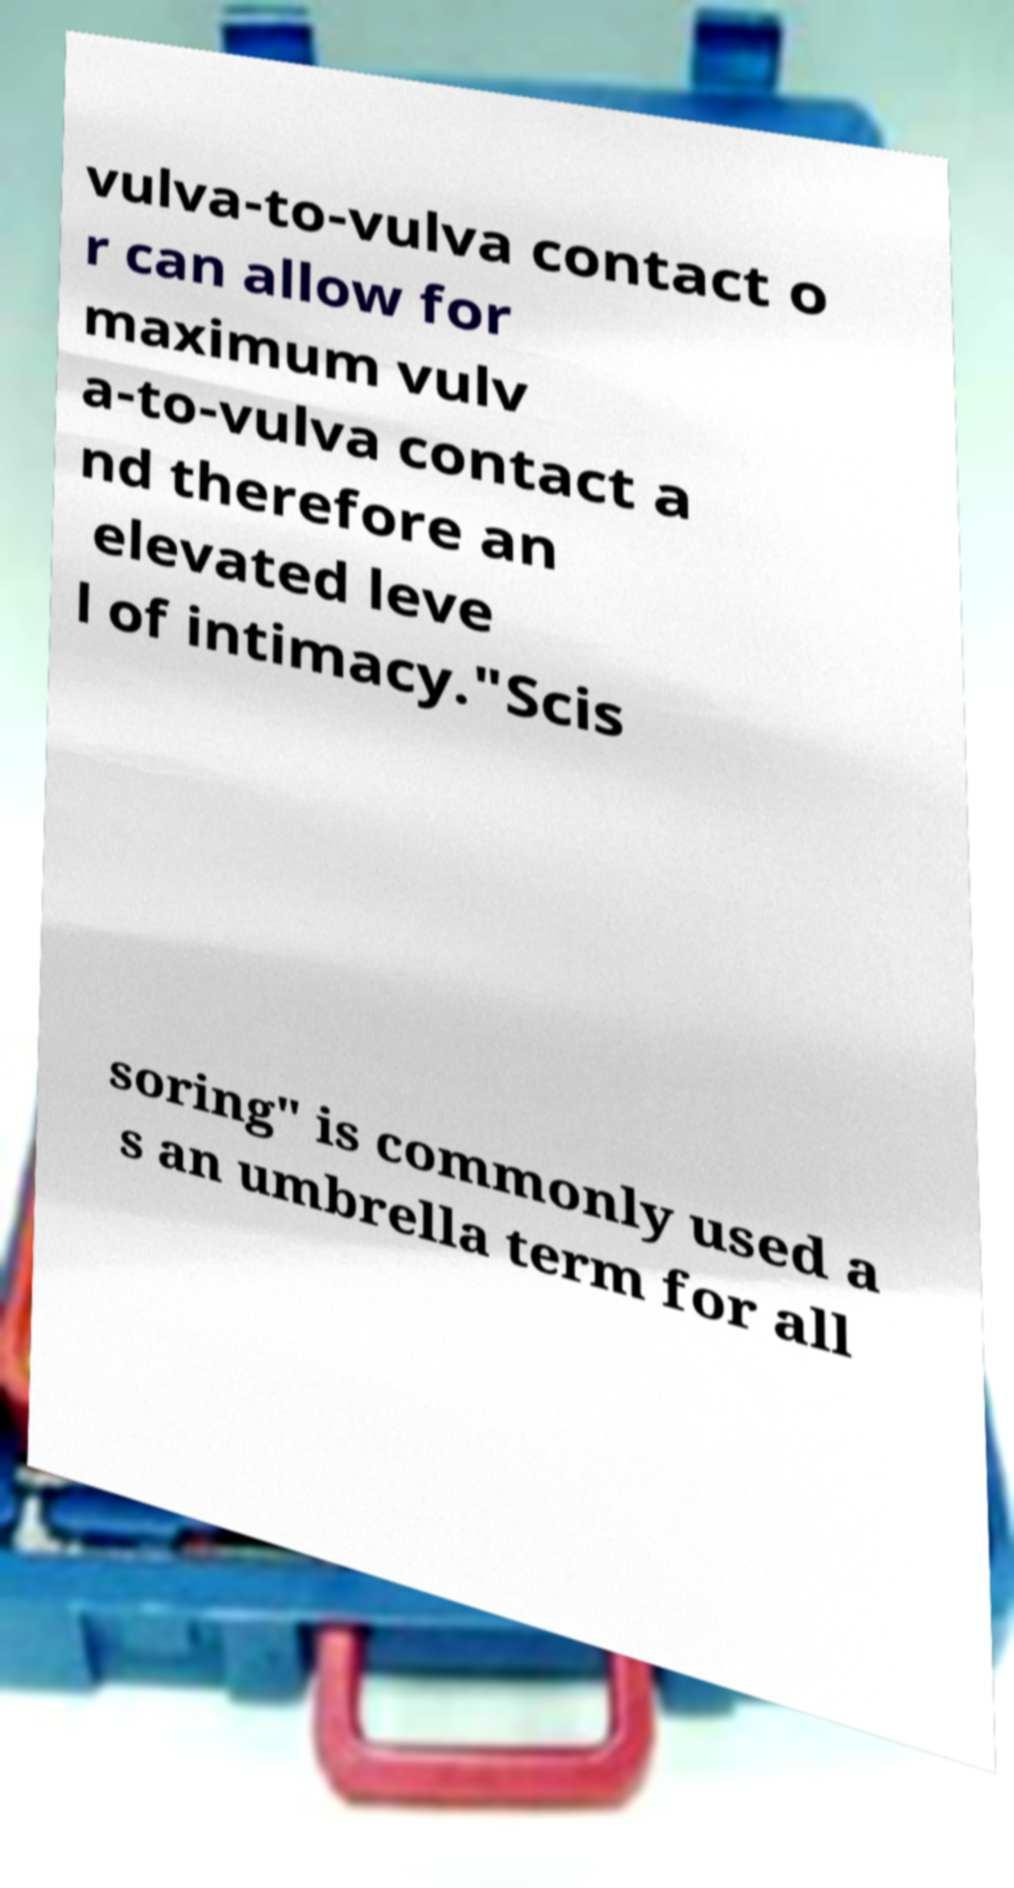Please read and relay the text visible in this image. What does it say? vulva-to-vulva contact o r can allow for maximum vulv a-to-vulva contact a nd therefore an elevated leve l of intimacy."Scis soring" is commonly used a s an umbrella term for all 